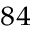<formula> <loc_0><loc_0><loc_500><loc_500>^ { 8 4 }</formula> 